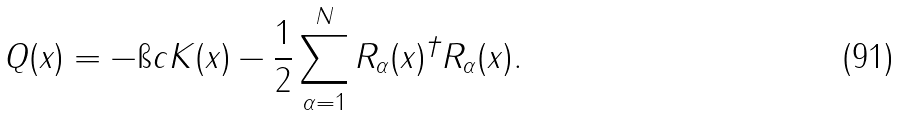Convert formula to latex. <formula><loc_0><loc_0><loc_500><loc_500>Q ( x ) = - \i c K ( x ) - \frac { 1 } { 2 } \sum _ { \alpha = 1 } ^ { N } R _ { \alpha } ( x ) ^ { \dagger } R _ { \alpha } ( x ) .</formula> 